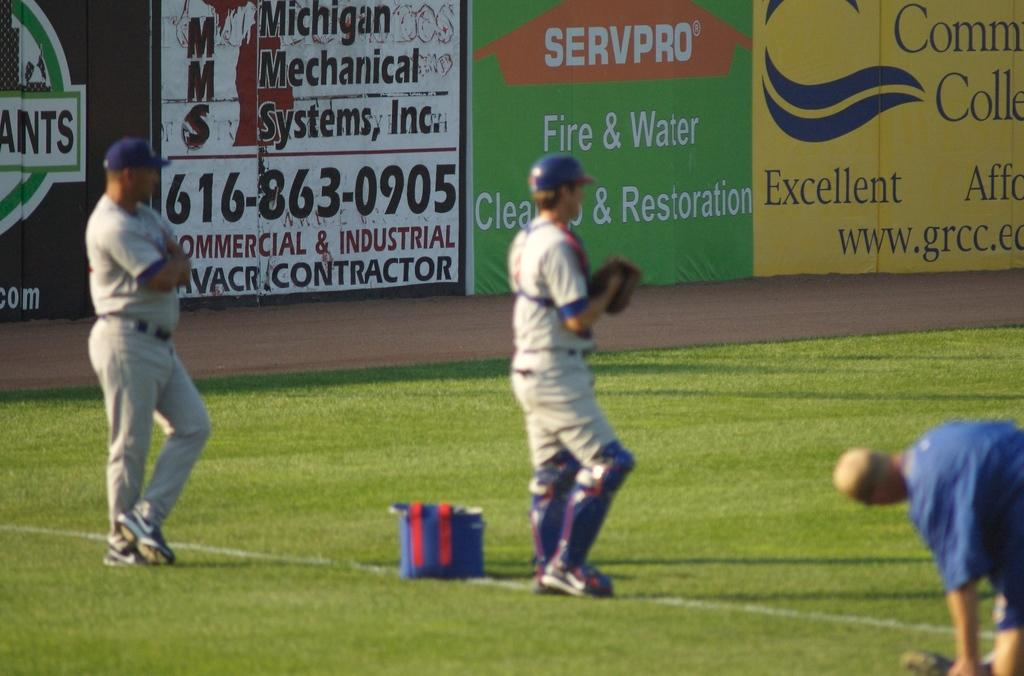<image>
Describe the image concisely. Baseball players warm up on the field in front of a Servpro fire and water sign. 